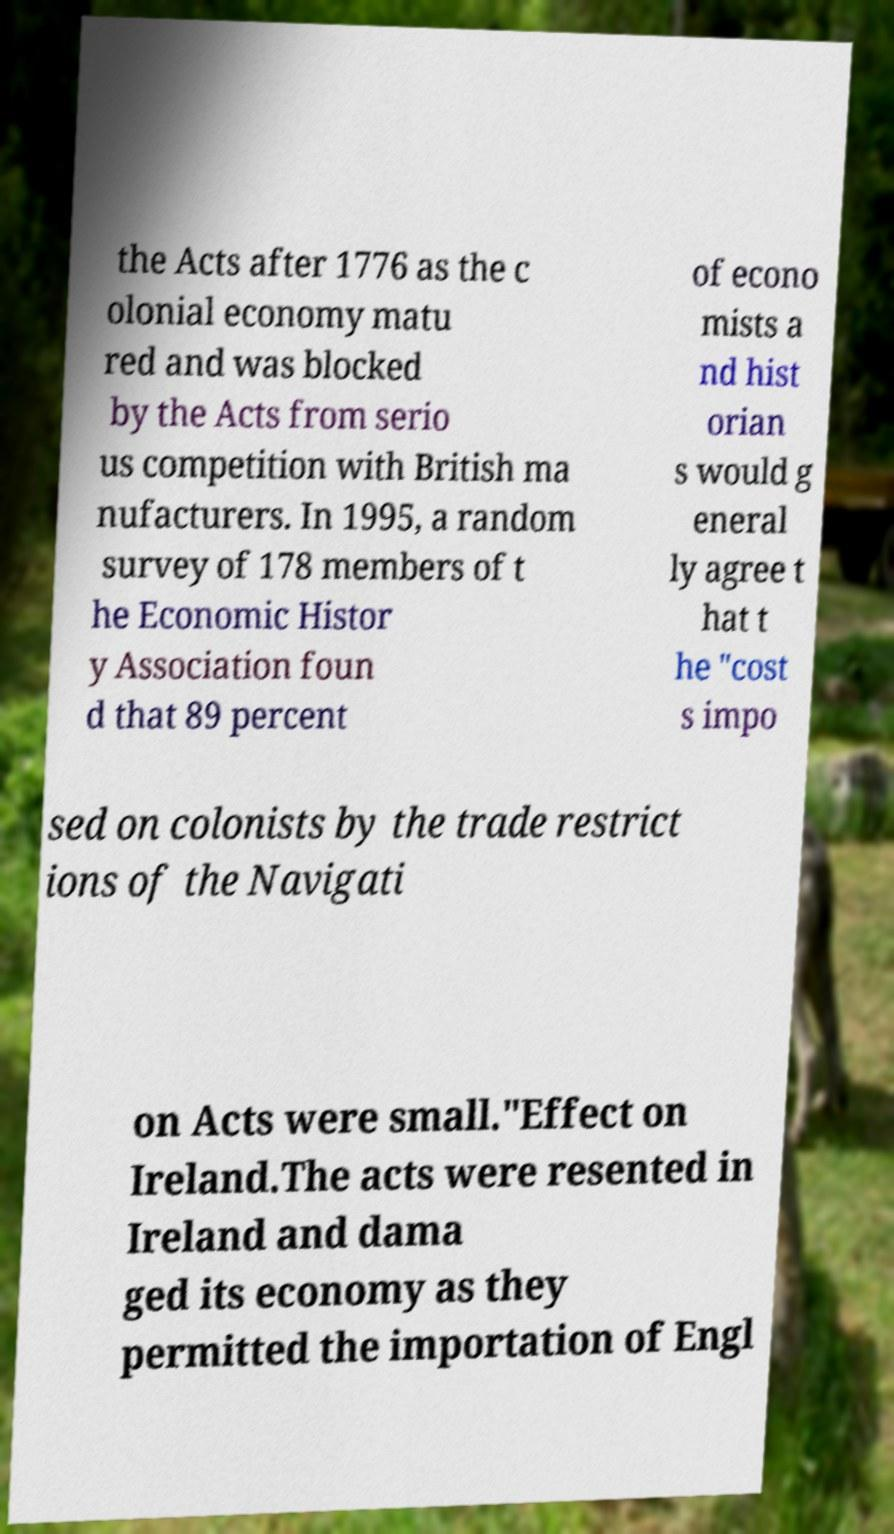Please read and relay the text visible in this image. What does it say? the Acts after 1776 as the c olonial economy matu red and was blocked by the Acts from serio us competition with British ma nufacturers. In 1995, a random survey of 178 members of t he Economic Histor y Association foun d that 89 percent of econo mists a nd hist orian s would g eneral ly agree t hat t he "cost s impo sed on colonists by the trade restrict ions of the Navigati on Acts were small."Effect on Ireland.The acts were resented in Ireland and dama ged its economy as they permitted the importation of Engl 